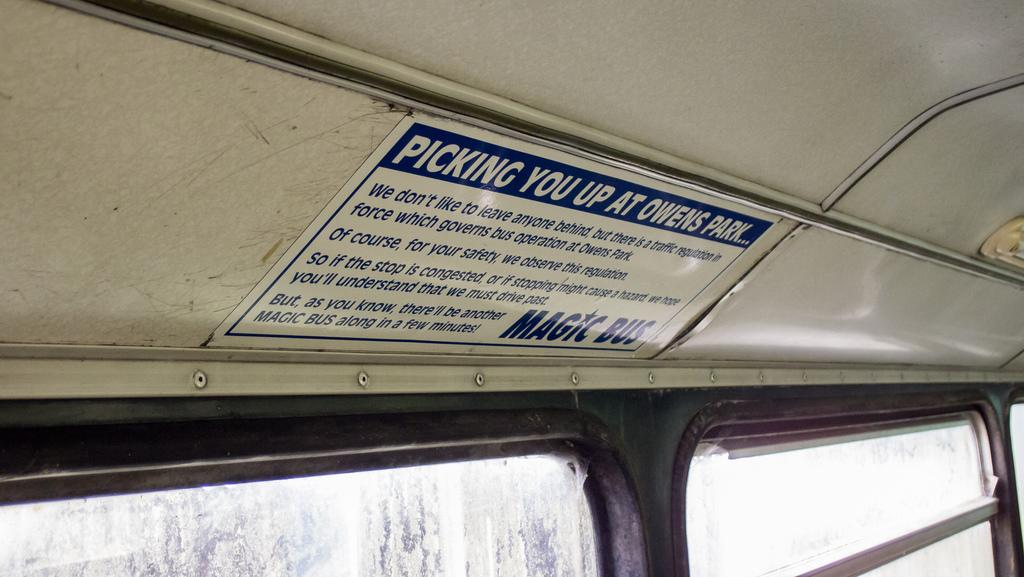What is the setting of the image? The picture is taken inside a bus. What can be seen at the bottom of the image? There are windows at the bottom of the image. What is in the middle of the image? There is a poster with text in the middle of the image. Where is the poster located on the bus? The poster is pasted on the top of the bus. How many ants can be seen crawling on the poster in the image? There are no ants present in the image; it only features a poster with text. What type of brain is required to understand the text on the poster? The image does not provide information about the complexity of the text or the brain required to understand it. 